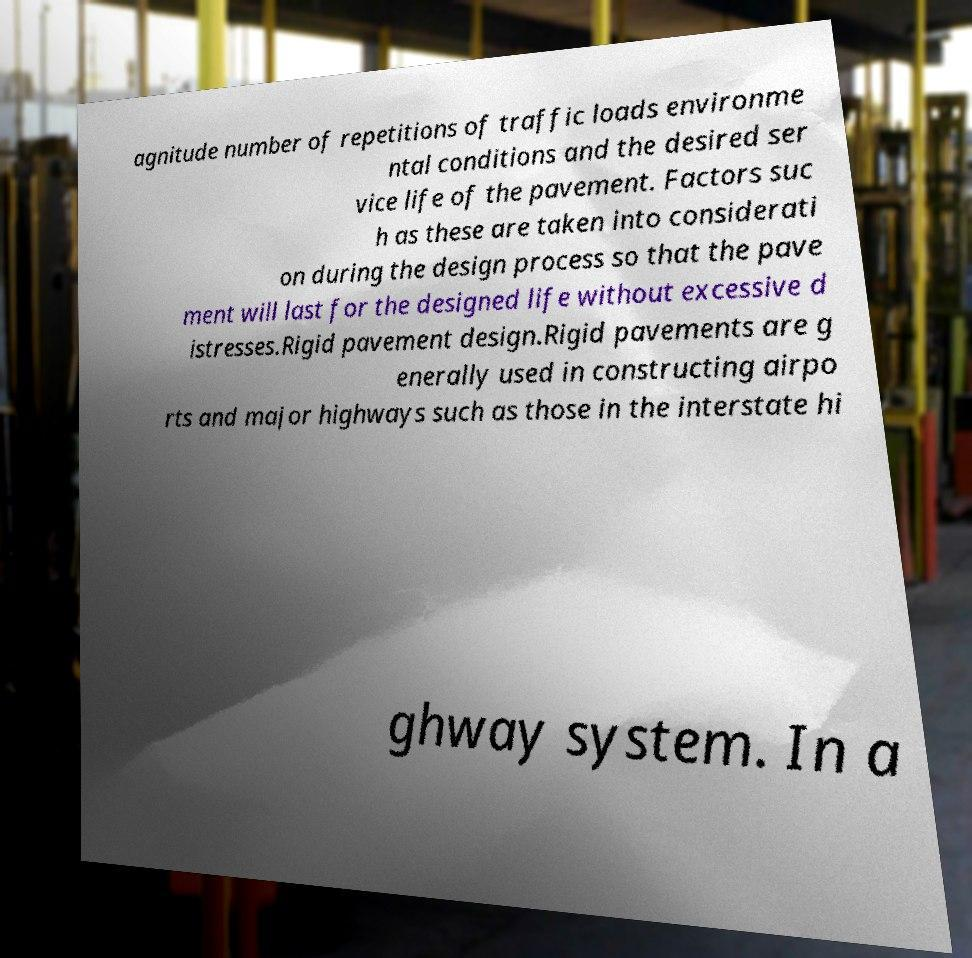What messages or text are displayed in this image? I need them in a readable, typed format. agnitude number of repetitions of traffic loads environme ntal conditions and the desired ser vice life of the pavement. Factors suc h as these are taken into considerati on during the design process so that the pave ment will last for the designed life without excessive d istresses.Rigid pavement design.Rigid pavements are g enerally used in constructing airpo rts and major highways such as those in the interstate hi ghway system. In a 